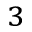<formula> <loc_0><loc_0><loc_500><loc_500>^ { 3 }</formula> 